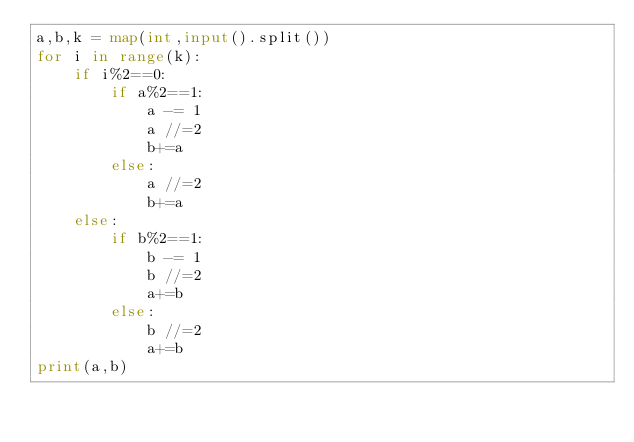Convert code to text. <code><loc_0><loc_0><loc_500><loc_500><_Python_>a,b,k = map(int,input().split())
for i in range(k):
    if i%2==0:
        if a%2==1:
            a -= 1
            a //=2
            b+=a
        else:
            a //=2
            b+=a
    else:
        if b%2==1:
            b -= 1
            b //=2
            a+=b
        else:
            b //=2
            a+=b
print(a,b)</code> 